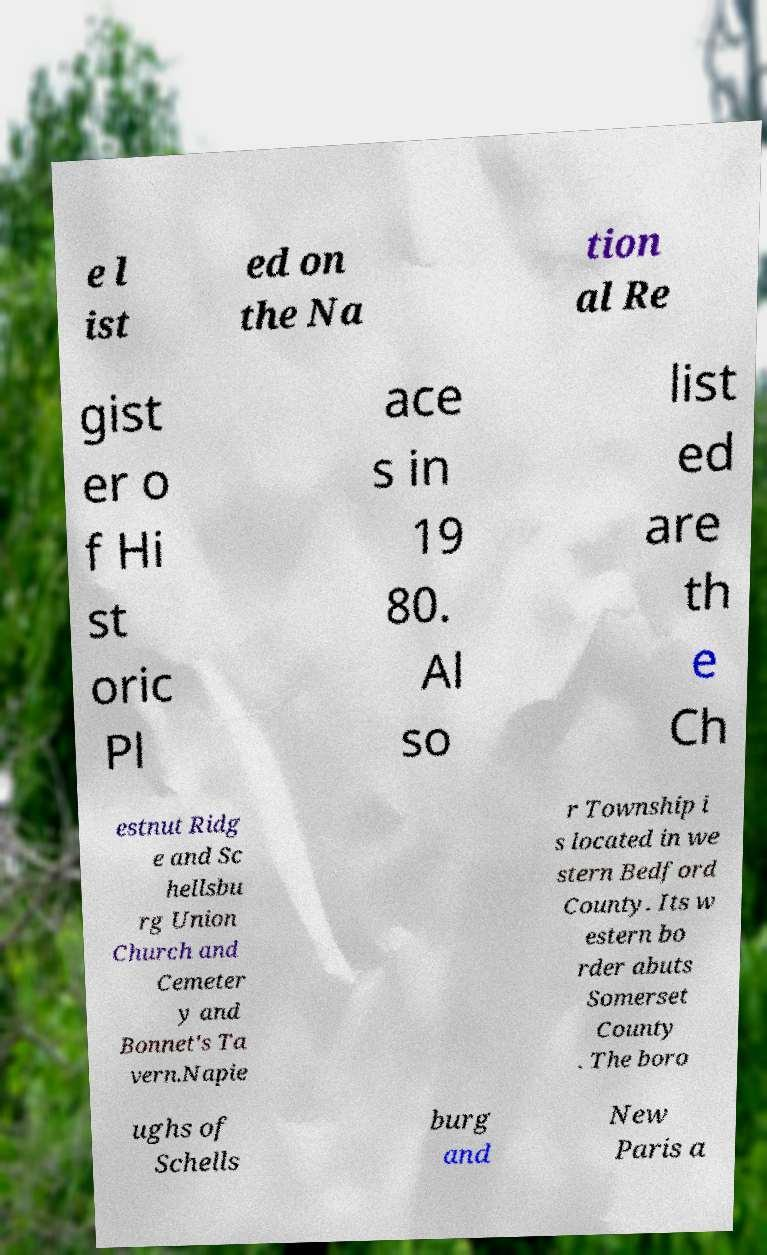Can you read and provide the text displayed in the image?This photo seems to have some interesting text. Can you extract and type it out for me? e l ist ed on the Na tion al Re gist er o f Hi st oric Pl ace s in 19 80. Al so list ed are th e Ch estnut Ridg e and Sc hellsbu rg Union Church and Cemeter y and Bonnet's Ta vern.Napie r Township i s located in we stern Bedford County. Its w estern bo rder abuts Somerset County . The boro ughs of Schells burg and New Paris a 